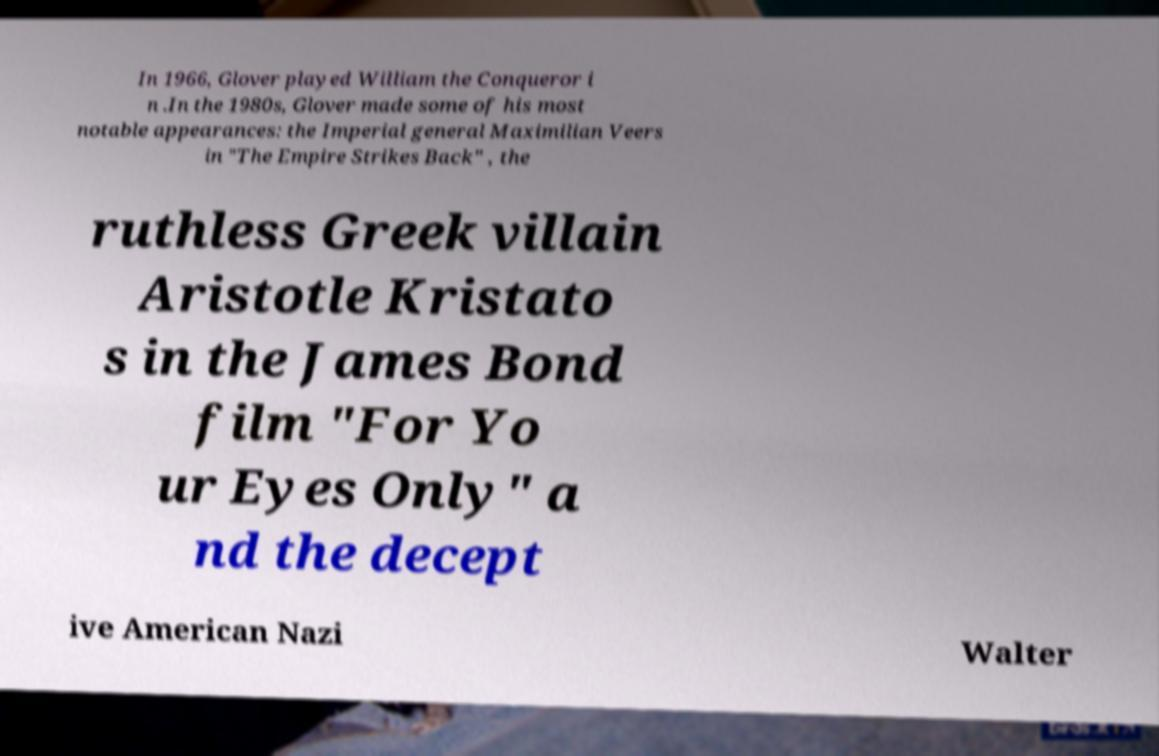Could you assist in decoding the text presented in this image and type it out clearly? In 1966, Glover played William the Conqueror i n .In the 1980s, Glover made some of his most notable appearances: the Imperial general Maximilian Veers in "The Empire Strikes Back" , the ruthless Greek villain Aristotle Kristato s in the James Bond film "For Yo ur Eyes Only" a nd the decept ive American Nazi Walter 